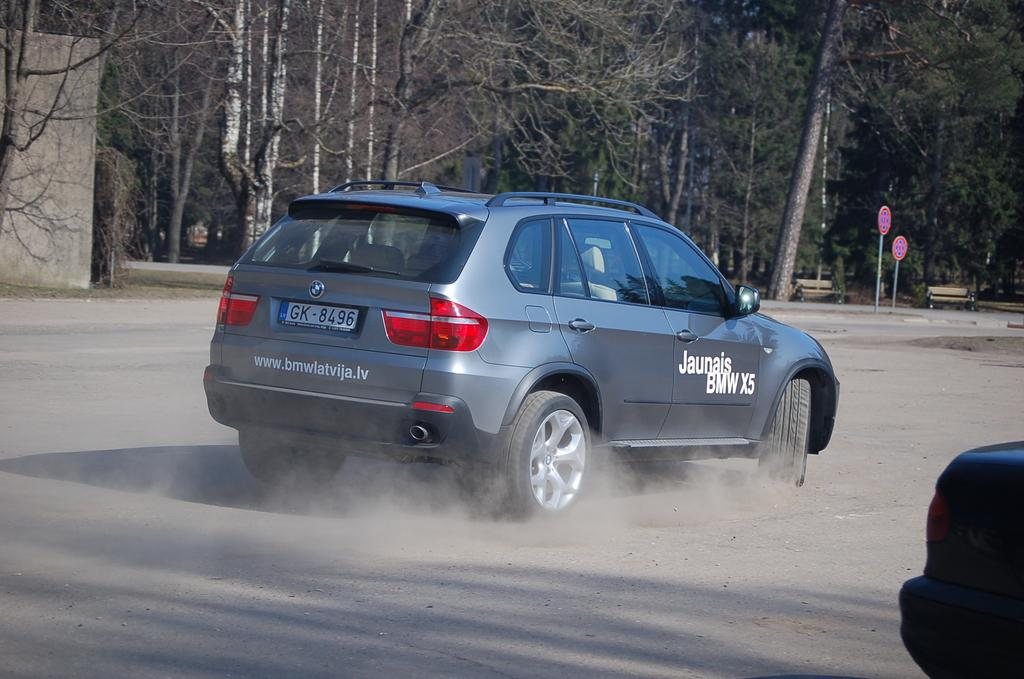<image>
Present a compact description of the photo's key features. A car with smoking tires has a Jaunais BMW X5 written in white lettering on the side. 